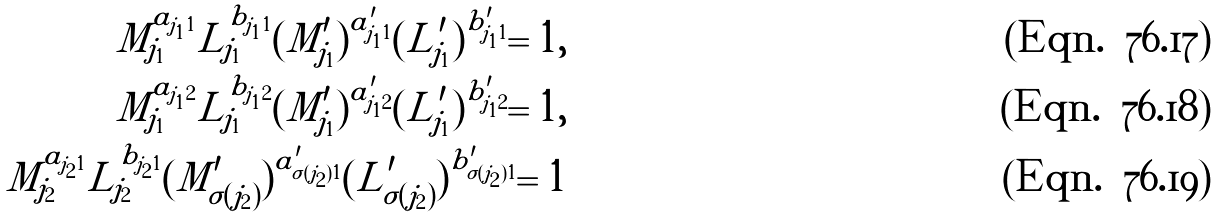<formula> <loc_0><loc_0><loc_500><loc_500>M _ { j _ { 1 } } ^ { a _ { j _ { 1 } 1 } } L _ { j _ { 1 } } ^ { b _ { j _ { 1 } 1 } } ( M ^ { \prime } _ { j _ { 1 } } ) ^ { a ^ { \prime } _ { j _ { 1 } 1 } } ( L ^ { \prime } _ { j _ { 1 } } ) ^ { b ^ { \prime } _ { j _ { 1 } 1 } } = 1 , \\ M _ { j _ { 1 } } ^ { a _ { j _ { 1 } 2 } } L _ { j _ { 1 } } ^ { b _ { j _ { 1 } 2 } } ( M ^ { \prime } _ { j _ { 1 } } ) ^ { a ^ { \prime } _ { j _ { 1 } 2 } } ( L ^ { \prime } _ { j _ { 1 } } ) ^ { b ^ { \prime } _ { j _ { 1 } 2 } } = 1 , \\ M _ { j _ { 2 } } ^ { a _ { j _ { 2 } 1 } } L _ { j _ { 2 } } ^ { b _ { j _ { 2 } 1 } } ( M ^ { \prime } _ { \sigma ( j _ { 2 } ) } ) ^ { a ^ { \prime } _ { \sigma ( j _ { 2 } ) 1 } } ( L ^ { \prime } _ { \sigma ( j _ { 2 } ) } ) ^ { b ^ { \prime } _ { \sigma ( j _ { 2 } ) 1 } } = 1</formula> 